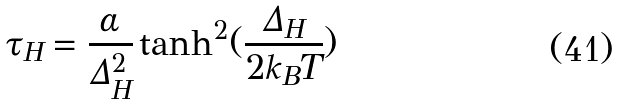Convert formula to latex. <formula><loc_0><loc_0><loc_500><loc_500>\tau _ { H } = \frac { \alpha } { \Delta _ { H } ^ { 2 } } \tanh ^ { 2 } ( \frac { \Delta _ { H } } { 2 k _ { B } T } )</formula> 